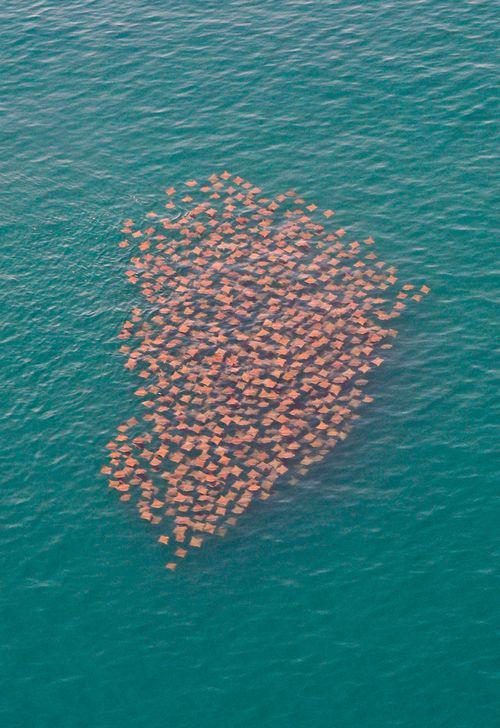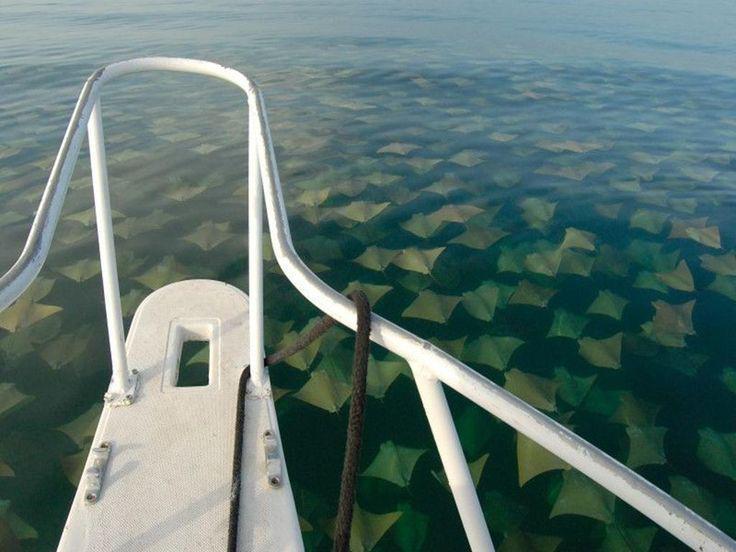The first image is the image on the left, the second image is the image on the right. Evaluate the accuracy of this statement regarding the images: "An image shows a mass of jellyfish along with something manmade that moves through the water.". Is it true? Answer yes or no. Yes. The first image is the image on the left, the second image is the image on the right. Given the left and right images, does the statement "A single ray is swimming near the sand in the image on the left." hold true? Answer yes or no. No. 